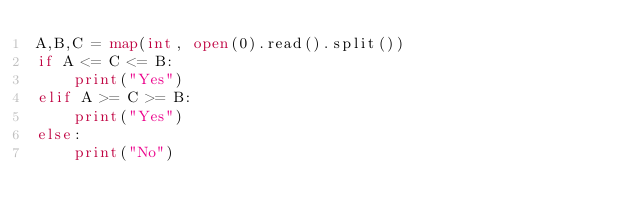Convert code to text. <code><loc_0><loc_0><loc_500><loc_500><_Python_>A,B,C = map(int, open(0).read().split())
if A <= C <= B:
    print("Yes")
elif A >= C >= B:
    print("Yes")
else:
    print("No")</code> 